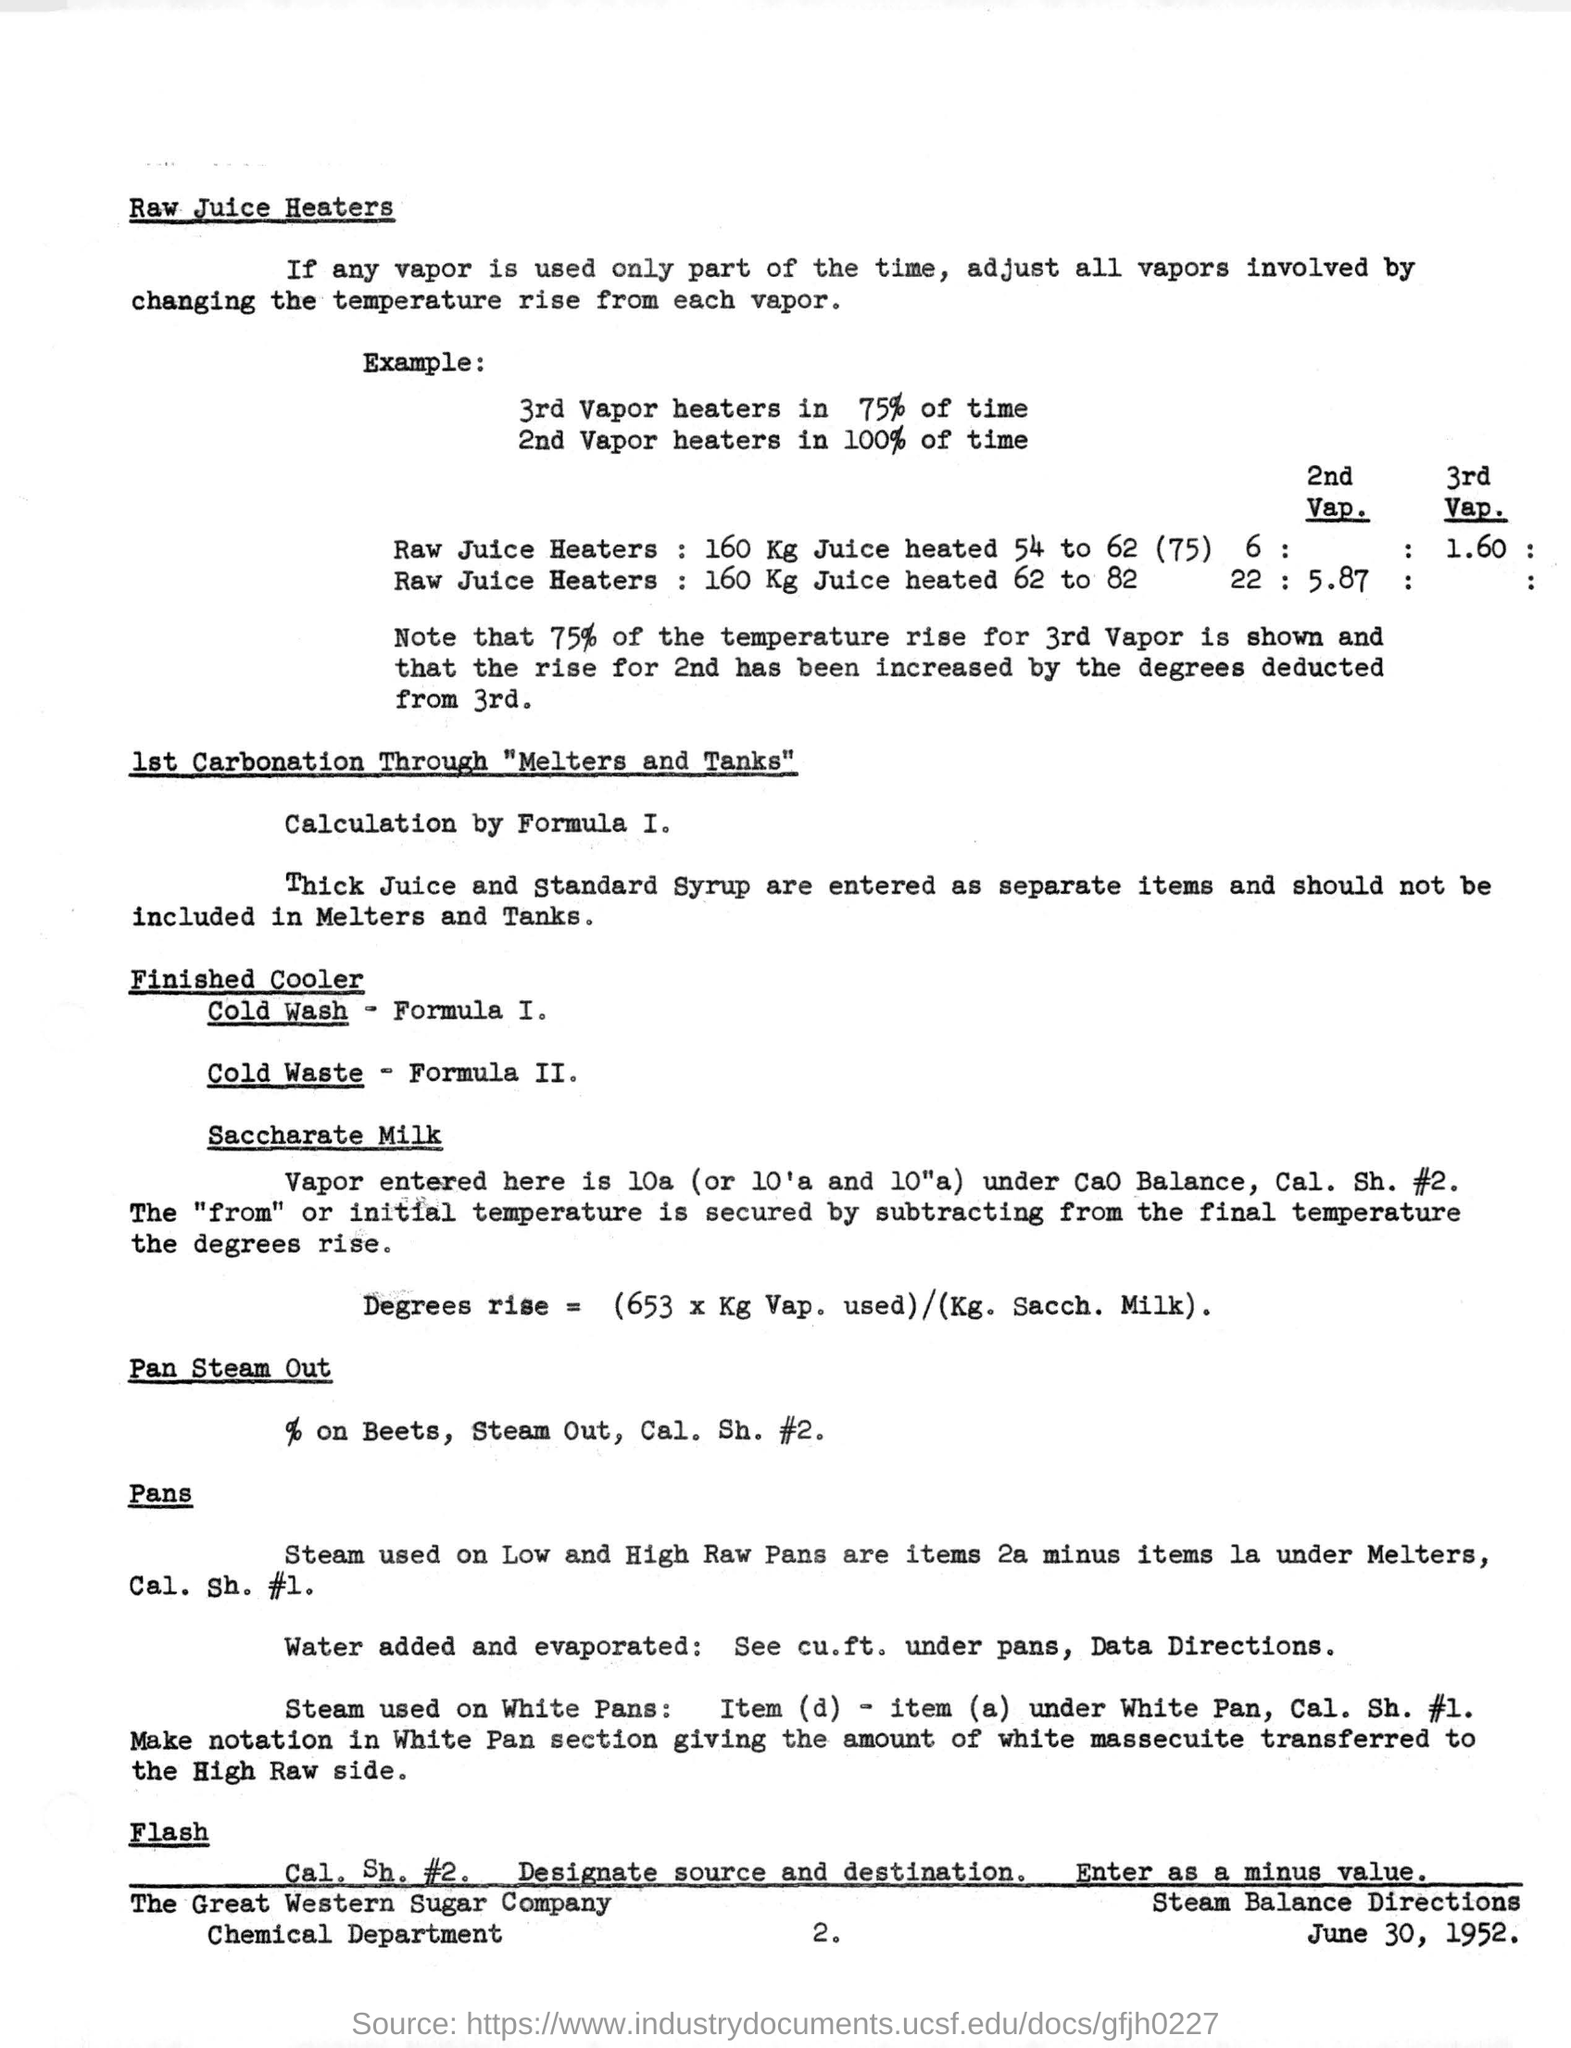What is the date mentioned in the bottom of the document ?
Give a very brief answer. June 30, 1952. What is the company name written in the bottom of the document ?
Your answer should be very brief. The Great Western Sugar Company. What is the number written in the bottom of the document ?
Provide a succinct answer. 2. What is the percentage of 3rd Vapor heaters ?
Your response must be concise. 75%. What is the Formula I. for Finished cooler ?
Your answer should be compact. COLD WASH. 